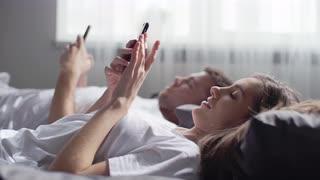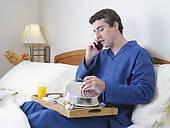The first image is the image on the left, the second image is the image on the right. Evaluate the accuracy of this statement regarding the images: "the right image shows a man in a seated position wearing blue, long sleeved pajamas". Is it true? Answer yes or no. Yes. The first image is the image on the left, the second image is the image on the right. Analyze the images presented: Is the assertion "An image includes one forward-facing man in sleepwear who is lifting a corded black telephone to his ear, and the other image shows a man standing wearing grey sweatpants." valid? Answer yes or no. No. 